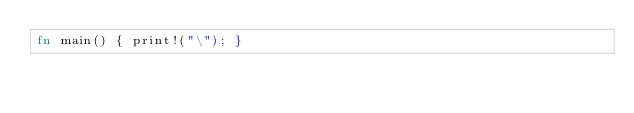<code> <loc_0><loc_0><loc_500><loc_500><_Rust_>fn main() { print!("\"); }
</code> 